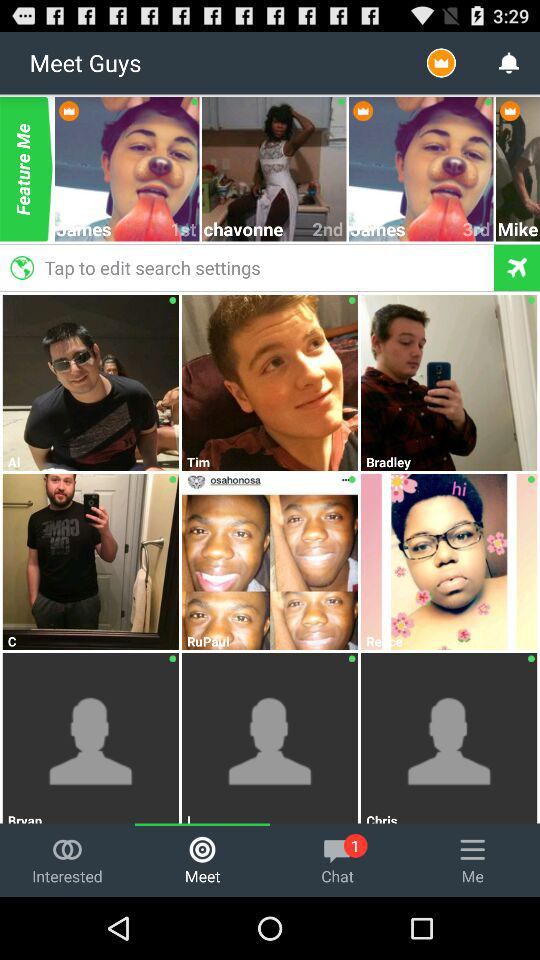Who is listed in "Interested"?
When the provided information is insufficient, respond with <no answer>. <no answer> 